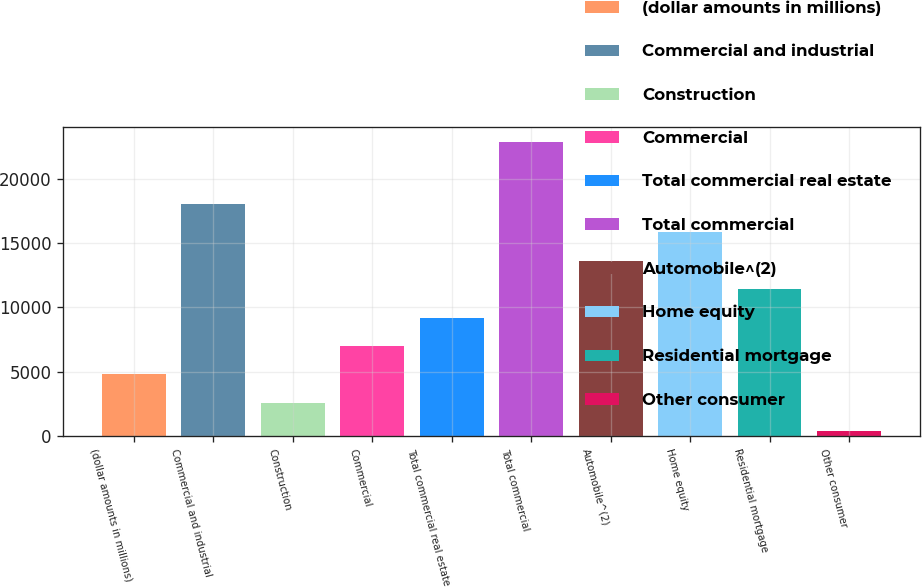Convert chart. <chart><loc_0><loc_0><loc_500><loc_500><bar_chart><fcel>(dollar amounts in millions)<fcel>Commercial and industrial<fcel>Construction<fcel>Commercial<fcel>Total commercial real estate<fcel>Total commercial<fcel>Automobile^(2)<fcel>Home equity<fcel>Residential mortgage<fcel>Other consumer<nl><fcel>4792.8<fcel>18031.2<fcel>2586.4<fcel>6999.2<fcel>9205.6<fcel>22882.4<fcel>13618.4<fcel>15824.8<fcel>11412<fcel>380<nl></chart> 